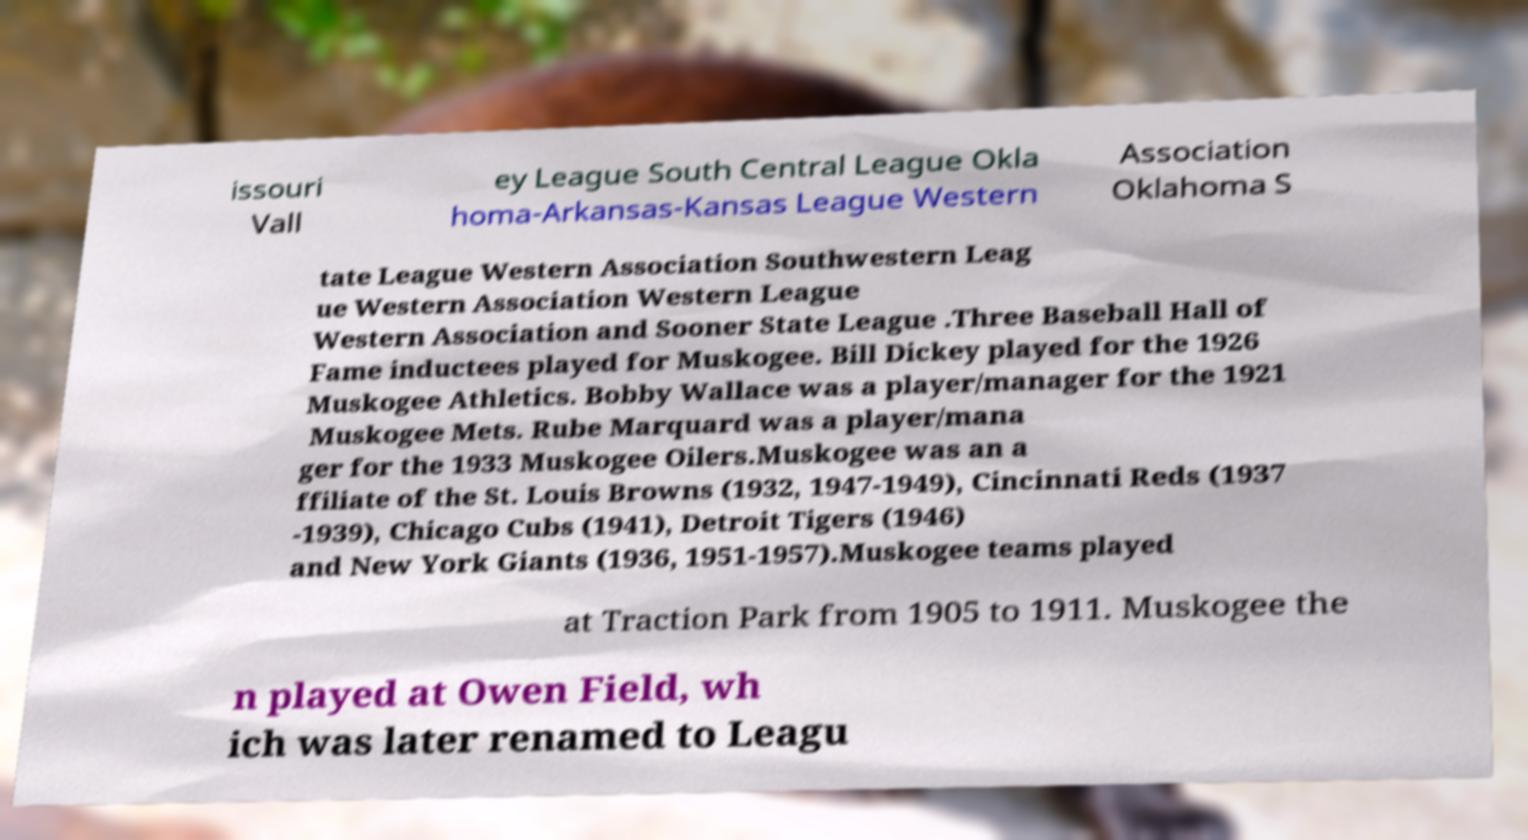There's text embedded in this image that I need extracted. Can you transcribe it verbatim? issouri Vall ey League South Central League Okla homa-Arkansas-Kansas League Western Association Oklahoma S tate League Western Association Southwestern Leag ue Western Association Western League Western Association and Sooner State League .Three Baseball Hall of Fame inductees played for Muskogee. Bill Dickey played for the 1926 Muskogee Athletics. Bobby Wallace was a player/manager for the 1921 Muskogee Mets. Rube Marquard was a player/mana ger for the 1933 Muskogee Oilers.Muskogee was an a ffiliate of the St. Louis Browns (1932, 1947-1949), Cincinnati Reds (1937 -1939), Chicago Cubs (1941), Detroit Tigers (1946) and New York Giants (1936, 1951-1957).Muskogee teams played at Traction Park from 1905 to 1911. Muskogee the n played at Owen Field, wh ich was later renamed to Leagu 